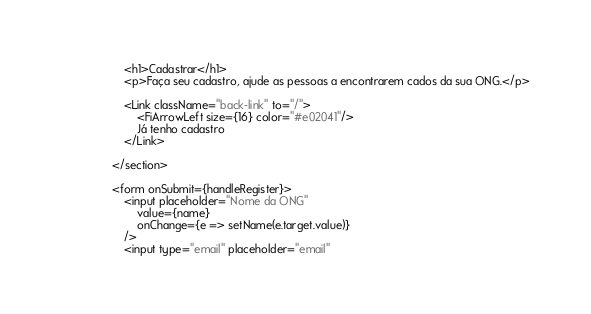Convert code to text. <code><loc_0><loc_0><loc_500><loc_500><_JavaScript_>                    <h1>Cadastrar</h1>
                    <p>Faça seu cadastro, ajude as pessoas a encontrarem cados da sua ONG.</p>
               
                    <Link className="back-link" to="/">
                        <FiArrowLeft size={16} color="#e02041"/>
                        Já tenho cadastro
                    </Link>

                </section>

                <form onSubmit={handleRegister}>
                    <input placeholder="Nome da ONG"
                        value={name}
                        onChange={e => setName(e.target.value)}
                    />
                    <input type="email" placeholder="email"</code> 